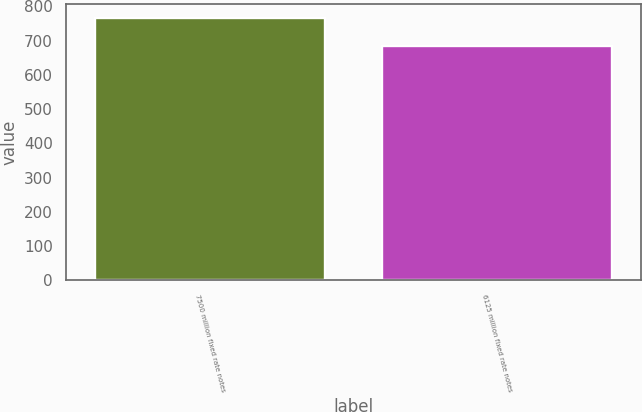<chart> <loc_0><loc_0><loc_500><loc_500><bar_chart><fcel>7500 million fixed rate notes<fcel>6125 million fixed rate notes<nl><fcel>767.1<fcel>684<nl></chart> 